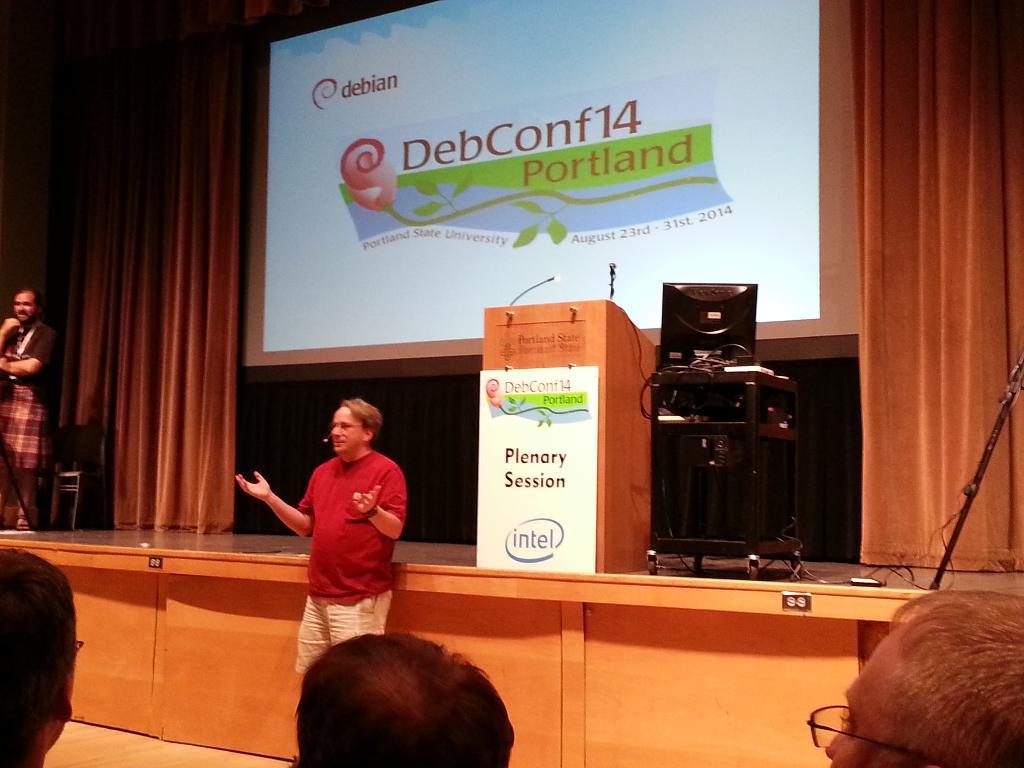In one or two sentences, can you explain what this image depicts? In this image I can see a person wearing red and cream colored dress is standing and I can see three persons heads. I can see the stage and on it I can see a podium, a table on which I can see a monitor and few other objects and a person standing. In the background I can see the curtains and a screen. 